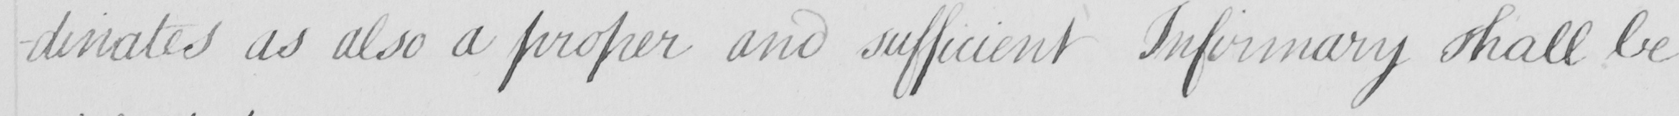Please provide the text content of this handwritten line. -dinates as also a proper and sufficient Infirmary shall be 